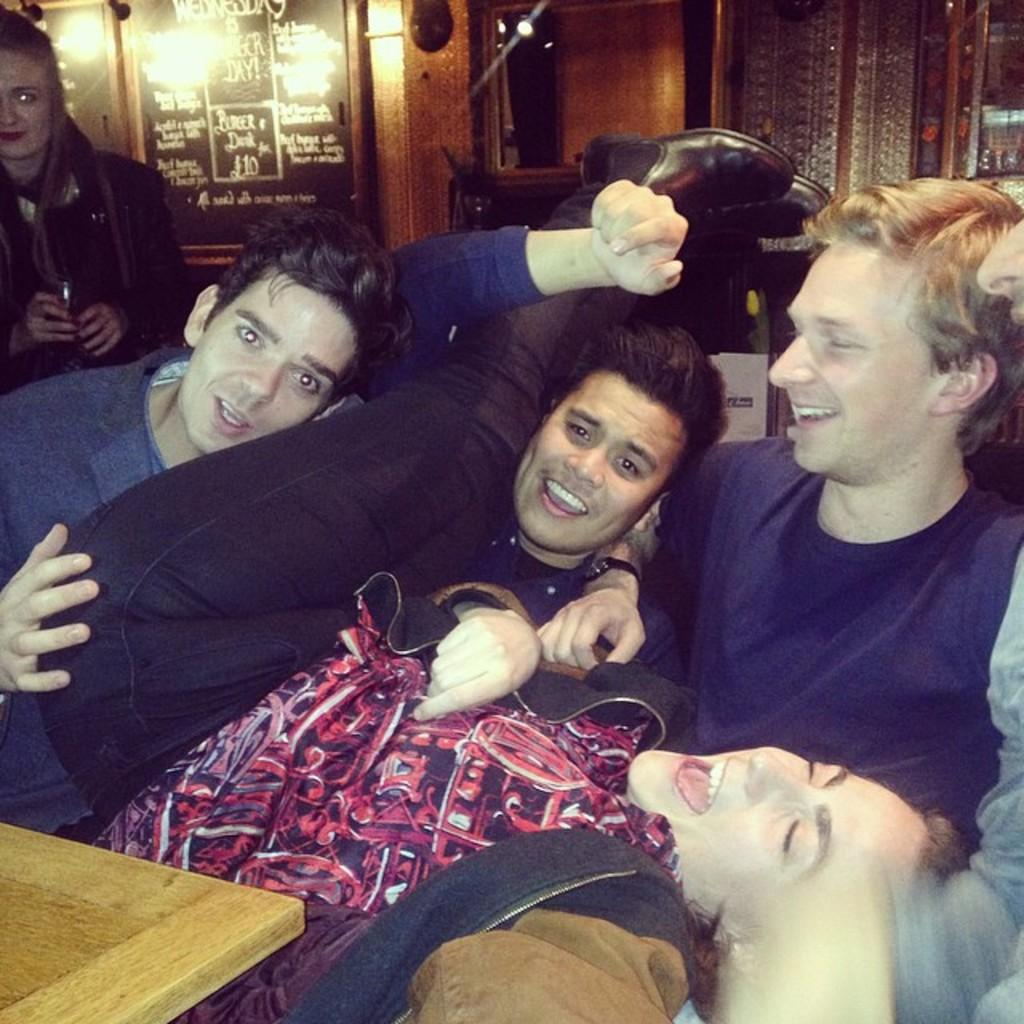How many people are present in the image? There are people in the image, but the exact number is not specified. What is located in front of the people? There is a table in front of the people. What can be seen in the background of the image? There are lights, a mirror, and a board with text in the background of the image. Can you tell me how many attempts the people in the image are making to cross the river? There is no river present in the image, so it is not possible to determine how many attempts the people are making to cross it. 